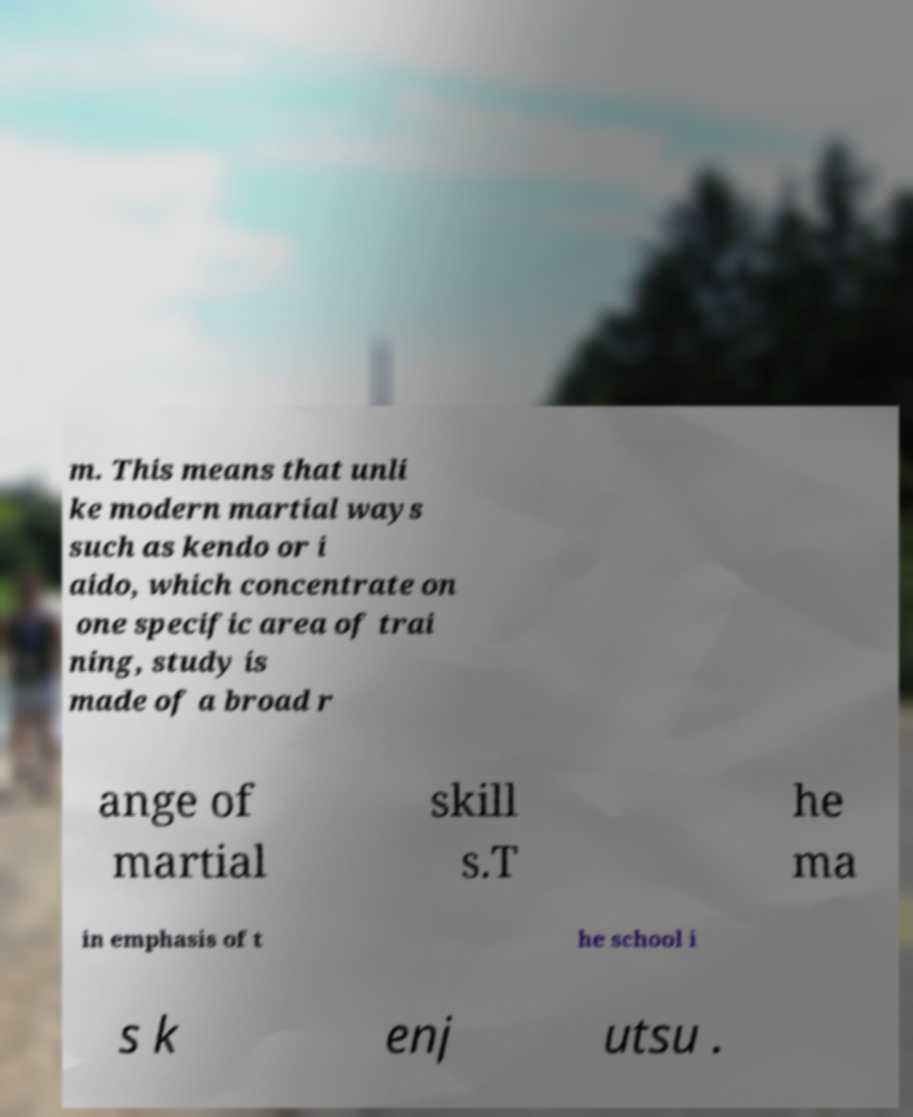Can you accurately transcribe the text from the provided image for me? m. This means that unli ke modern martial ways such as kendo or i aido, which concentrate on one specific area of trai ning, study is made of a broad r ange of martial skill s.T he ma in emphasis of t he school i s k enj utsu . 